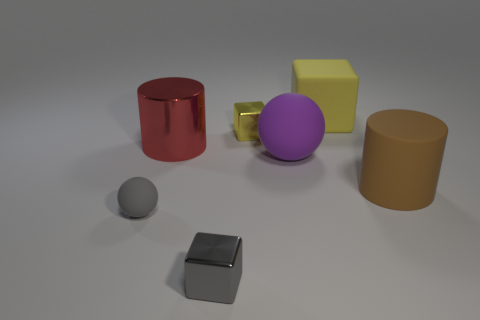There is a small thing that is both in front of the tiny yellow shiny block and on the right side of the red shiny thing; what is its material?
Offer a very short reply. Metal. There is a small gray object that is to the right of the red metallic cylinder; is it the same shape as the object to the right of the large rubber block?
Provide a short and direct response. No. Is there any other thing that is the same shape as the gray rubber thing?
Ensure brevity in your answer.  Yes. What is the material of the big brown object that is on the right side of the tiny yellow shiny cube?
Offer a very short reply. Rubber. The other yellow object that is the same shape as the yellow metal thing is what size?
Your answer should be very brief. Large. How many small gray things are made of the same material as the big red cylinder?
Provide a succinct answer. 1. What number of tiny blocks are the same color as the big metallic thing?
Make the answer very short. 0. What number of things are matte spheres in front of the rubber cylinder or balls left of the tiny gray cube?
Make the answer very short. 1. Are there fewer gray rubber things that are in front of the gray rubber ball than gray cubes?
Offer a terse response. Yes. Are there any brown matte things that have the same size as the gray matte object?
Keep it short and to the point. No. 